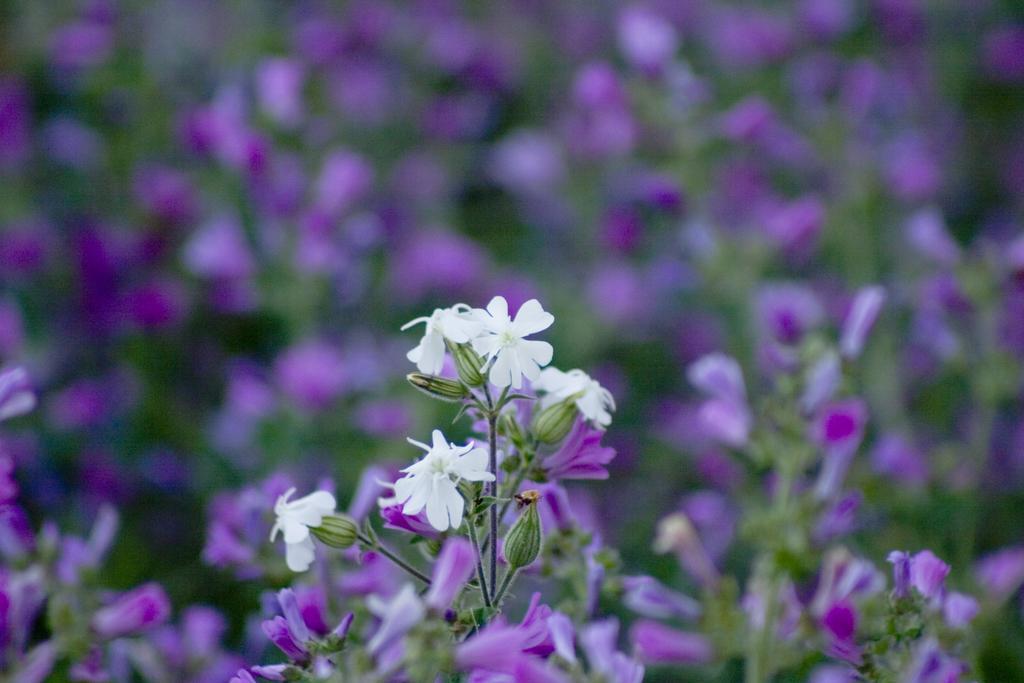Can you describe this image briefly? In this image I can see white and purple colour flowers. I can also see this image is little bit blurry from background. 